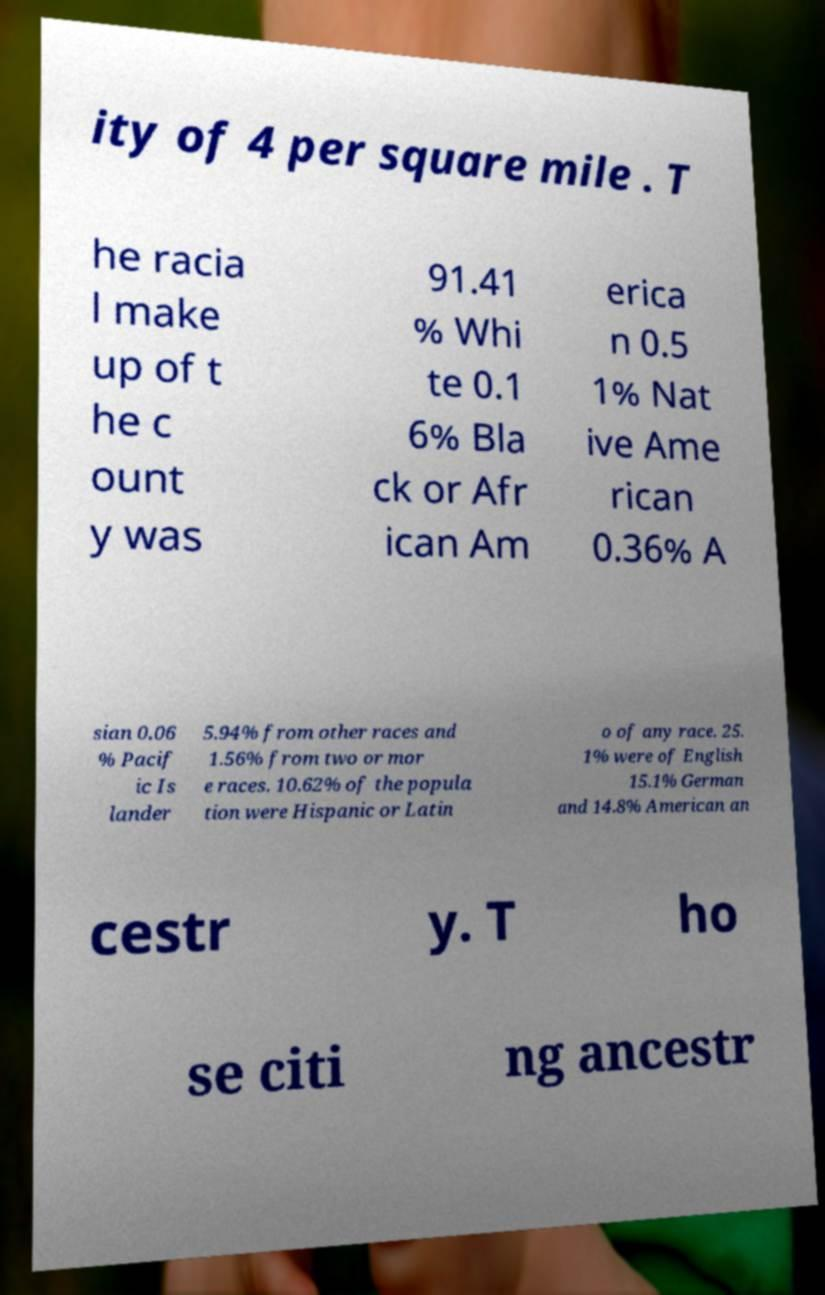For documentation purposes, I need the text within this image transcribed. Could you provide that? ity of 4 per square mile . T he racia l make up of t he c ount y was 91.41 % Whi te 0.1 6% Bla ck or Afr ican Am erica n 0.5 1% Nat ive Ame rican 0.36% A sian 0.06 % Pacif ic Is lander 5.94% from other races and 1.56% from two or mor e races. 10.62% of the popula tion were Hispanic or Latin o of any race. 25. 1% were of English 15.1% German and 14.8% American an cestr y. T ho se citi ng ancestr 